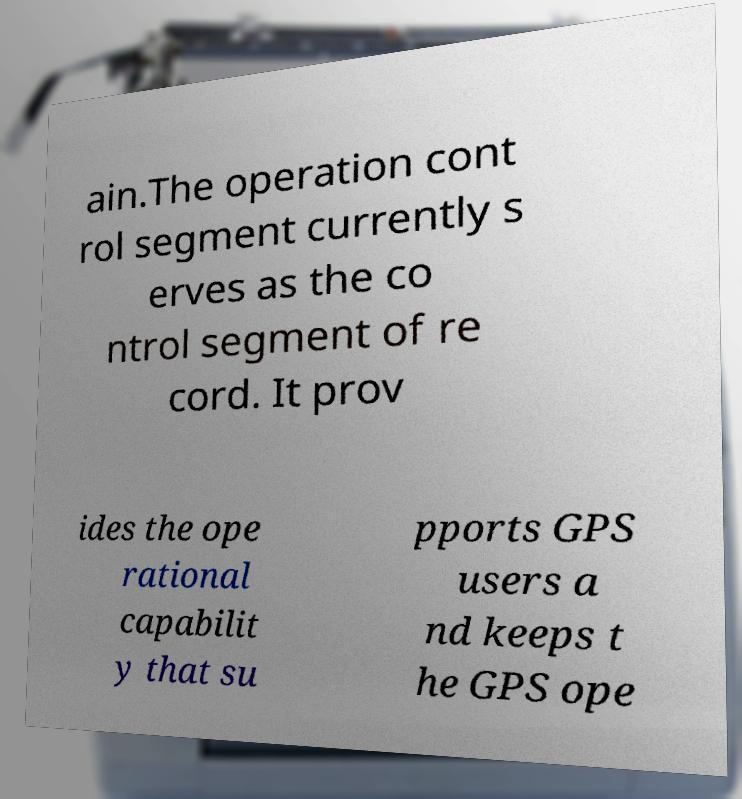Could you extract and type out the text from this image? ain.The operation cont rol segment currently s erves as the co ntrol segment of re cord. It prov ides the ope rational capabilit y that su pports GPS users a nd keeps t he GPS ope 